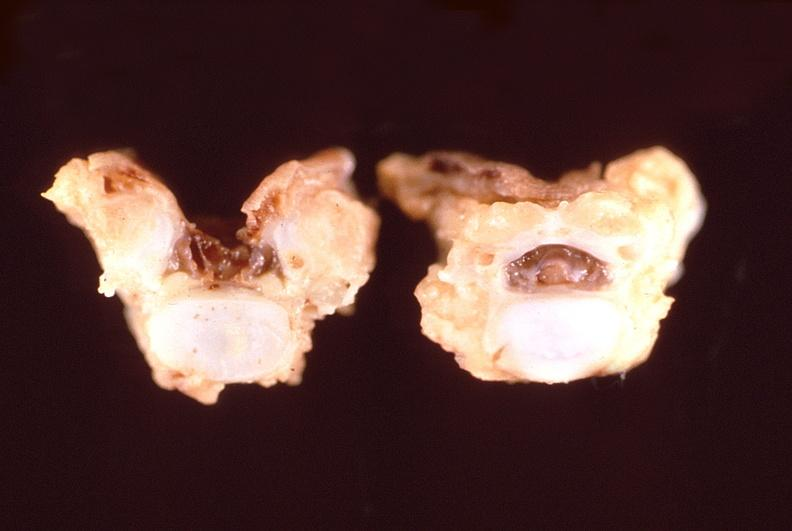s pituitary present?
Answer the question using a single word or phrase. No 